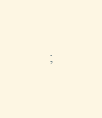Convert code to text. <code><loc_0><loc_0><loc_500><loc_500><_SQL_>;
</code> 